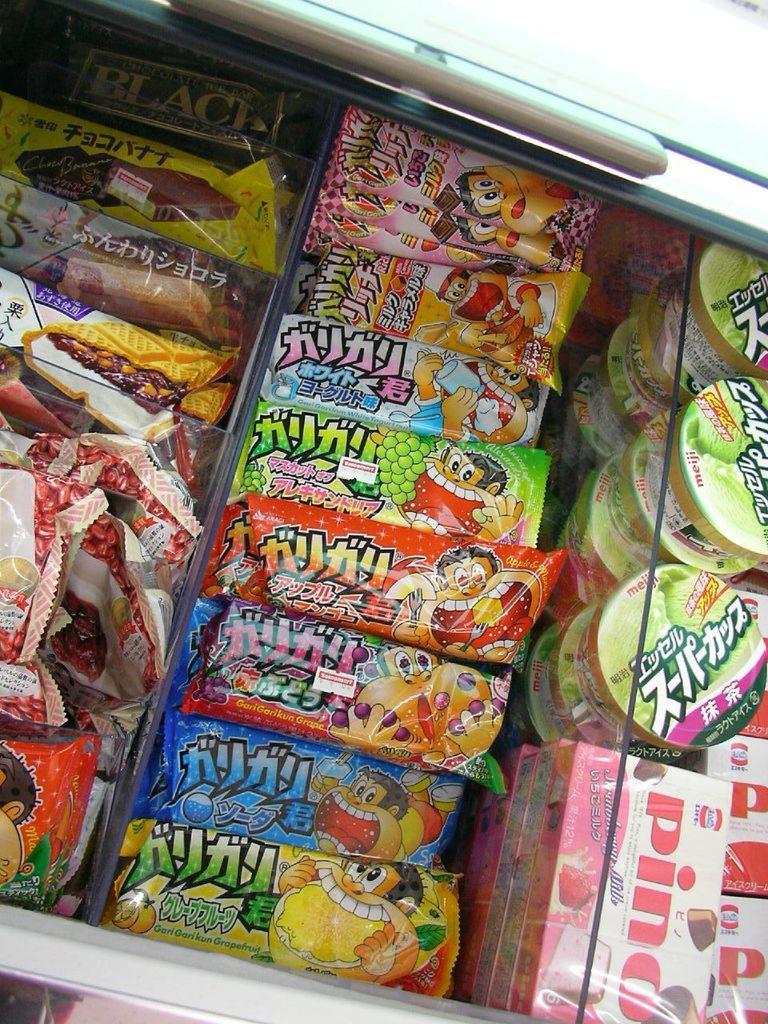What name is on the pink and white box?
Give a very brief answer. Pino. 